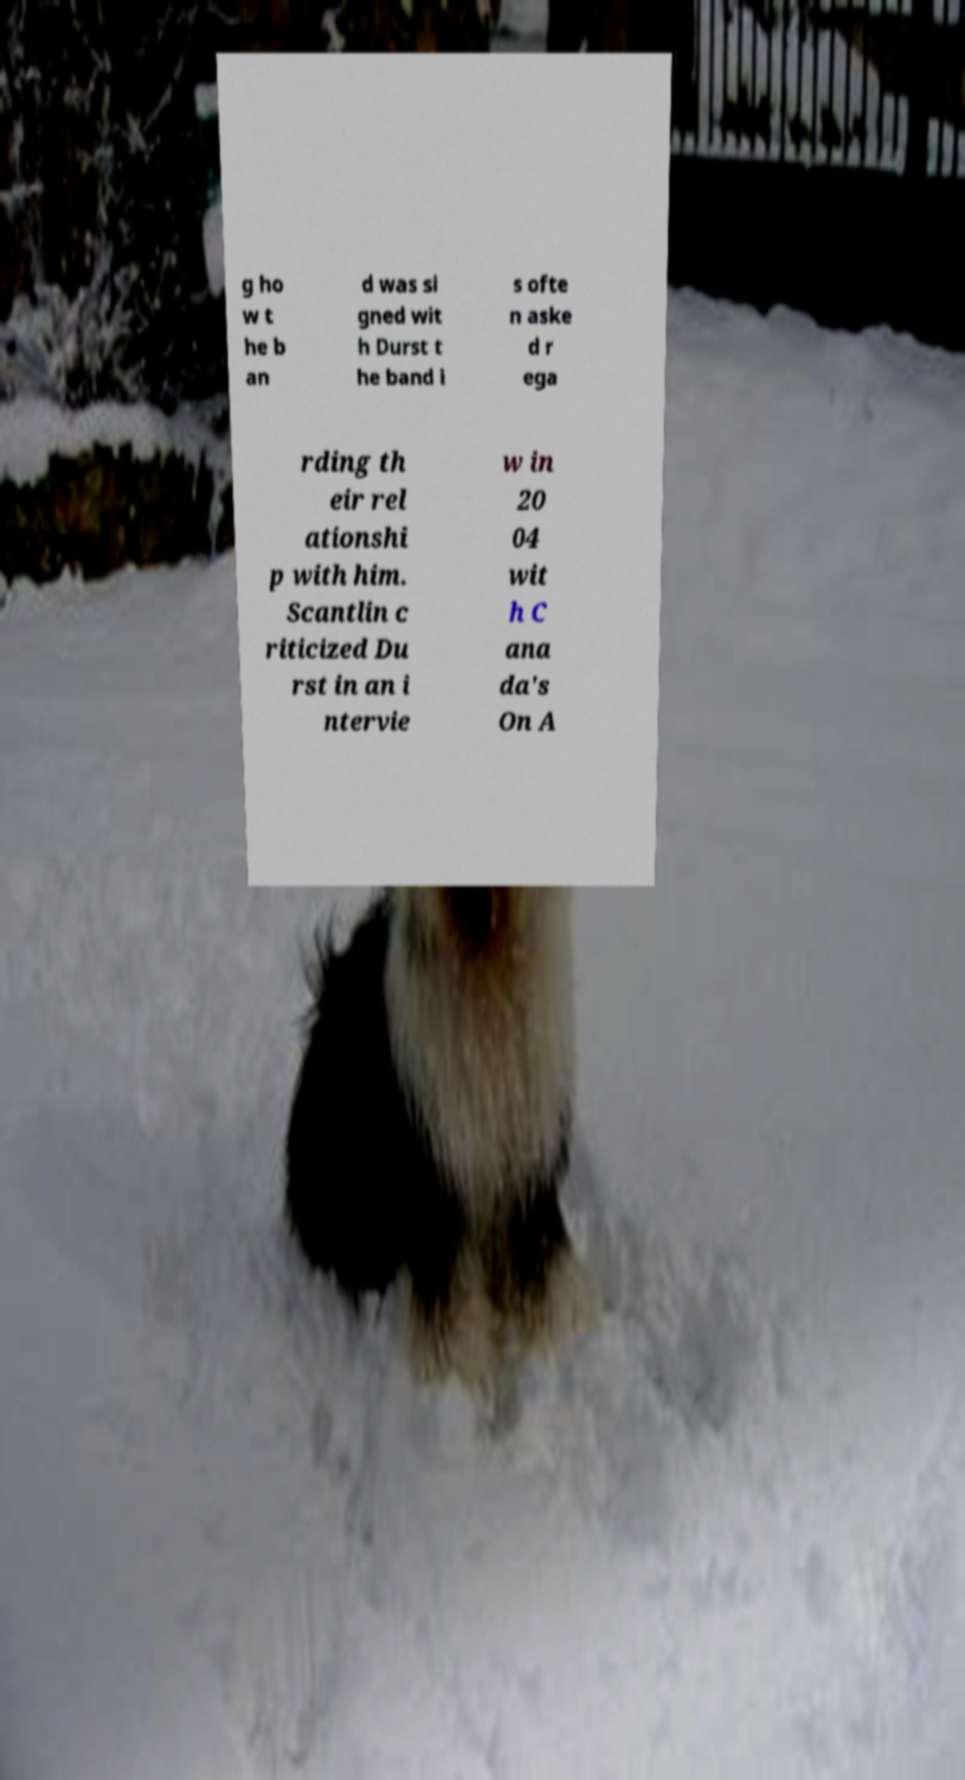Please identify and transcribe the text found in this image. g ho w t he b an d was si gned wit h Durst t he band i s ofte n aske d r ega rding th eir rel ationshi p with him. Scantlin c riticized Du rst in an i ntervie w in 20 04 wit h C ana da's On A 